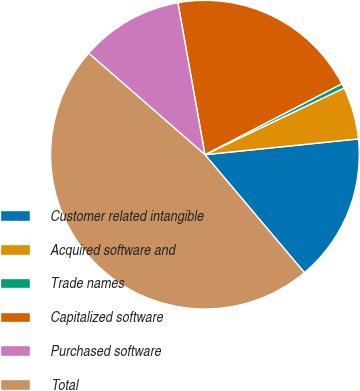<chart> <loc_0><loc_0><loc_500><loc_500><pie_chart><fcel>Customer related intangible<fcel>Acquired software and<fcel>Trade names<fcel>Capitalized software<fcel>Purchased software<fcel>Total<nl><fcel>15.48%<fcel>5.48%<fcel>0.5%<fcel>20.19%<fcel>10.78%<fcel>47.57%<nl></chart> 